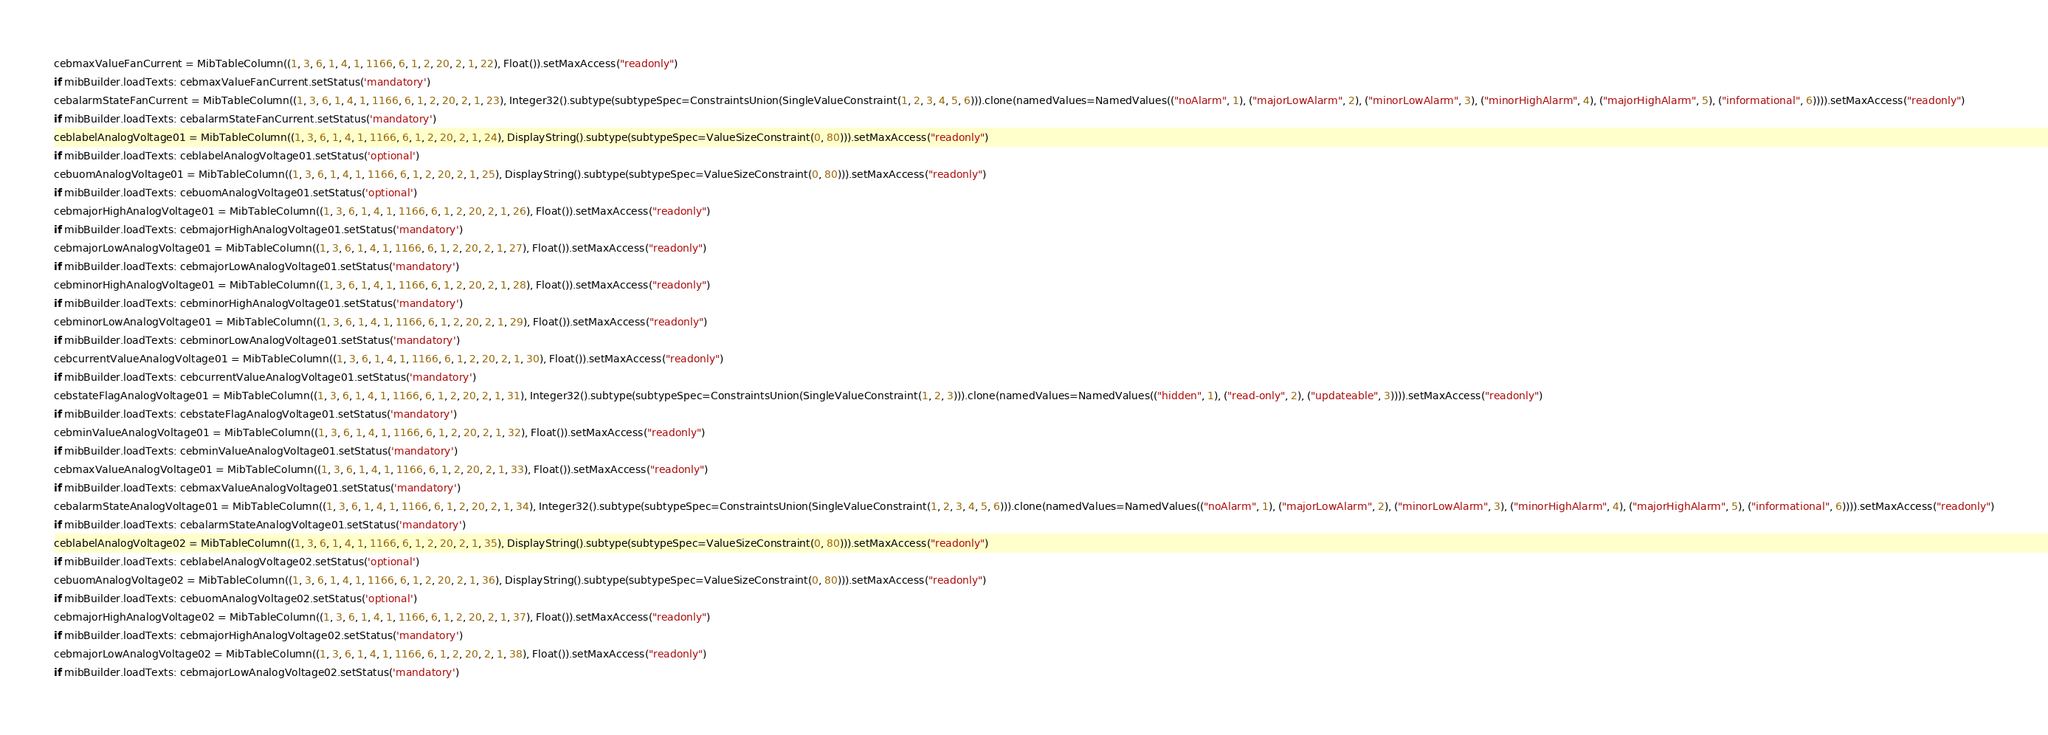<code> <loc_0><loc_0><loc_500><loc_500><_Python_>cebmaxValueFanCurrent = MibTableColumn((1, 3, 6, 1, 4, 1, 1166, 6, 1, 2, 20, 2, 1, 22), Float()).setMaxAccess("readonly")
if mibBuilder.loadTexts: cebmaxValueFanCurrent.setStatus('mandatory')
cebalarmStateFanCurrent = MibTableColumn((1, 3, 6, 1, 4, 1, 1166, 6, 1, 2, 20, 2, 1, 23), Integer32().subtype(subtypeSpec=ConstraintsUnion(SingleValueConstraint(1, 2, 3, 4, 5, 6))).clone(namedValues=NamedValues(("noAlarm", 1), ("majorLowAlarm", 2), ("minorLowAlarm", 3), ("minorHighAlarm", 4), ("majorHighAlarm", 5), ("informational", 6)))).setMaxAccess("readonly")
if mibBuilder.loadTexts: cebalarmStateFanCurrent.setStatus('mandatory')
ceblabelAnalogVoltage01 = MibTableColumn((1, 3, 6, 1, 4, 1, 1166, 6, 1, 2, 20, 2, 1, 24), DisplayString().subtype(subtypeSpec=ValueSizeConstraint(0, 80))).setMaxAccess("readonly")
if mibBuilder.loadTexts: ceblabelAnalogVoltage01.setStatus('optional')
cebuomAnalogVoltage01 = MibTableColumn((1, 3, 6, 1, 4, 1, 1166, 6, 1, 2, 20, 2, 1, 25), DisplayString().subtype(subtypeSpec=ValueSizeConstraint(0, 80))).setMaxAccess("readonly")
if mibBuilder.loadTexts: cebuomAnalogVoltage01.setStatus('optional')
cebmajorHighAnalogVoltage01 = MibTableColumn((1, 3, 6, 1, 4, 1, 1166, 6, 1, 2, 20, 2, 1, 26), Float()).setMaxAccess("readonly")
if mibBuilder.loadTexts: cebmajorHighAnalogVoltage01.setStatus('mandatory')
cebmajorLowAnalogVoltage01 = MibTableColumn((1, 3, 6, 1, 4, 1, 1166, 6, 1, 2, 20, 2, 1, 27), Float()).setMaxAccess("readonly")
if mibBuilder.loadTexts: cebmajorLowAnalogVoltage01.setStatus('mandatory')
cebminorHighAnalogVoltage01 = MibTableColumn((1, 3, 6, 1, 4, 1, 1166, 6, 1, 2, 20, 2, 1, 28), Float()).setMaxAccess("readonly")
if mibBuilder.loadTexts: cebminorHighAnalogVoltage01.setStatus('mandatory')
cebminorLowAnalogVoltage01 = MibTableColumn((1, 3, 6, 1, 4, 1, 1166, 6, 1, 2, 20, 2, 1, 29), Float()).setMaxAccess("readonly")
if mibBuilder.loadTexts: cebminorLowAnalogVoltage01.setStatus('mandatory')
cebcurrentValueAnalogVoltage01 = MibTableColumn((1, 3, 6, 1, 4, 1, 1166, 6, 1, 2, 20, 2, 1, 30), Float()).setMaxAccess("readonly")
if mibBuilder.loadTexts: cebcurrentValueAnalogVoltage01.setStatus('mandatory')
cebstateFlagAnalogVoltage01 = MibTableColumn((1, 3, 6, 1, 4, 1, 1166, 6, 1, 2, 20, 2, 1, 31), Integer32().subtype(subtypeSpec=ConstraintsUnion(SingleValueConstraint(1, 2, 3))).clone(namedValues=NamedValues(("hidden", 1), ("read-only", 2), ("updateable", 3)))).setMaxAccess("readonly")
if mibBuilder.loadTexts: cebstateFlagAnalogVoltage01.setStatus('mandatory')
cebminValueAnalogVoltage01 = MibTableColumn((1, 3, 6, 1, 4, 1, 1166, 6, 1, 2, 20, 2, 1, 32), Float()).setMaxAccess("readonly")
if mibBuilder.loadTexts: cebminValueAnalogVoltage01.setStatus('mandatory')
cebmaxValueAnalogVoltage01 = MibTableColumn((1, 3, 6, 1, 4, 1, 1166, 6, 1, 2, 20, 2, 1, 33), Float()).setMaxAccess("readonly")
if mibBuilder.loadTexts: cebmaxValueAnalogVoltage01.setStatus('mandatory')
cebalarmStateAnalogVoltage01 = MibTableColumn((1, 3, 6, 1, 4, 1, 1166, 6, 1, 2, 20, 2, 1, 34), Integer32().subtype(subtypeSpec=ConstraintsUnion(SingleValueConstraint(1, 2, 3, 4, 5, 6))).clone(namedValues=NamedValues(("noAlarm", 1), ("majorLowAlarm", 2), ("minorLowAlarm", 3), ("minorHighAlarm", 4), ("majorHighAlarm", 5), ("informational", 6)))).setMaxAccess("readonly")
if mibBuilder.loadTexts: cebalarmStateAnalogVoltage01.setStatus('mandatory')
ceblabelAnalogVoltage02 = MibTableColumn((1, 3, 6, 1, 4, 1, 1166, 6, 1, 2, 20, 2, 1, 35), DisplayString().subtype(subtypeSpec=ValueSizeConstraint(0, 80))).setMaxAccess("readonly")
if mibBuilder.loadTexts: ceblabelAnalogVoltage02.setStatus('optional')
cebuomAnalogVoltage02 = MibTableColumn((1, 3, 6, 1, 4, 1, 1166, 6, 1, 2, 20, 2, 1, 36), DisplayString().subtype(subtypeSpec=ValueSizeConstraint(0, 80))).setMaxAccess("readonly")
if mibBuilder.loadTexts: cebuomAnalogVoltage02.setStatus('optional')
cebmajorHighAnalogVoltage02 = MibTableColumn((1, 3, 6, 1, 4, 1, 1166, 6, 1, 2, 20, 2, 1, 37), Float()).setMaxAccess("readonly")
if mibBuilder.loadTexts: cebmajorHighAnalogVoltage02.setStatus('mandatory')
cebmajorLowAnalogVoltage02 = MibTableColumn((1, 3, 6, 1, 4, 1, 1166, 6, 1, 2, 20, 2, 1, 38), Float()).setMaxAccess("readonly")
if mibBuilder.loadTexts: cebmajorLowAnalogVoltage02.setStatus('mandatory')</code> 